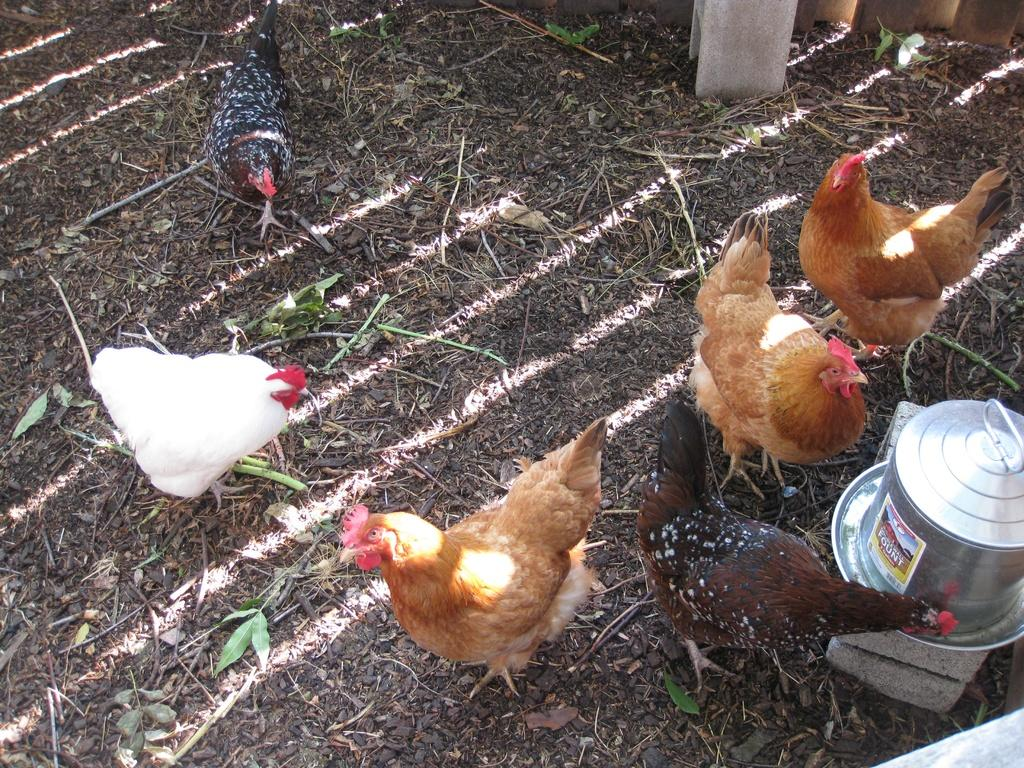What type of animals are present in the image? There are hens in the image. What natural elements can be seen in the image? There are twigs, leaves, and a wooden object in the image. What man-made materials are visible in the image? There are bricks and steel objects in the image. Can you describe the objects at the top of the image? There is a pole at the top of the image, and there is a wooden object as well. What other objects can be seen in the image besides the ones mentioned? There are other objects in the image, but their specific details are not provided in the facts. What type of hope can be seen in the image? There is no reference to hope in the image, as it features hens, twigs, leaves, bricks, steel objects, and other unspecified objects. What type of army is present in the image? There is no army present in the image; it features hens, twigs, leaves, bricks, steel objects, and other unspecified objects. 